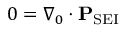Convert formula to latex. <formula><loc_0><loc_0><loc_500><loc_500>0 = \nabla _ { 0 } \cdot P _ { S E I }</formula> 